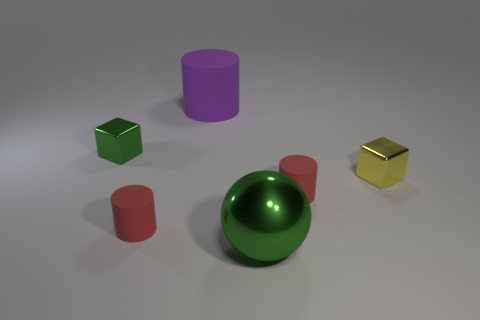Subtract all tiny red cylinders. How many cylinders are left? 1 Add 2 red spheres. How many objects exist? 8 Subtract all purple spheres. How many red cylinders are left? 2 Add 5 large purple rubber cylinders. How many large purple rubber cylinders exist? 6 Subtract 1 green balls. How many objects are left? 5 Subtract all blocks. How many objects are left? 4 Subtract 3 cylinders. How many cylinders are left? 0 Subtract all red blocks. Subtract all cyan balls. How many blocks are left? 2 Subtract all purple cylinders. Subtract all small green things. How many objects are left? 4 Add 5 small metal blocks. How many small metal blocks are left? 7 